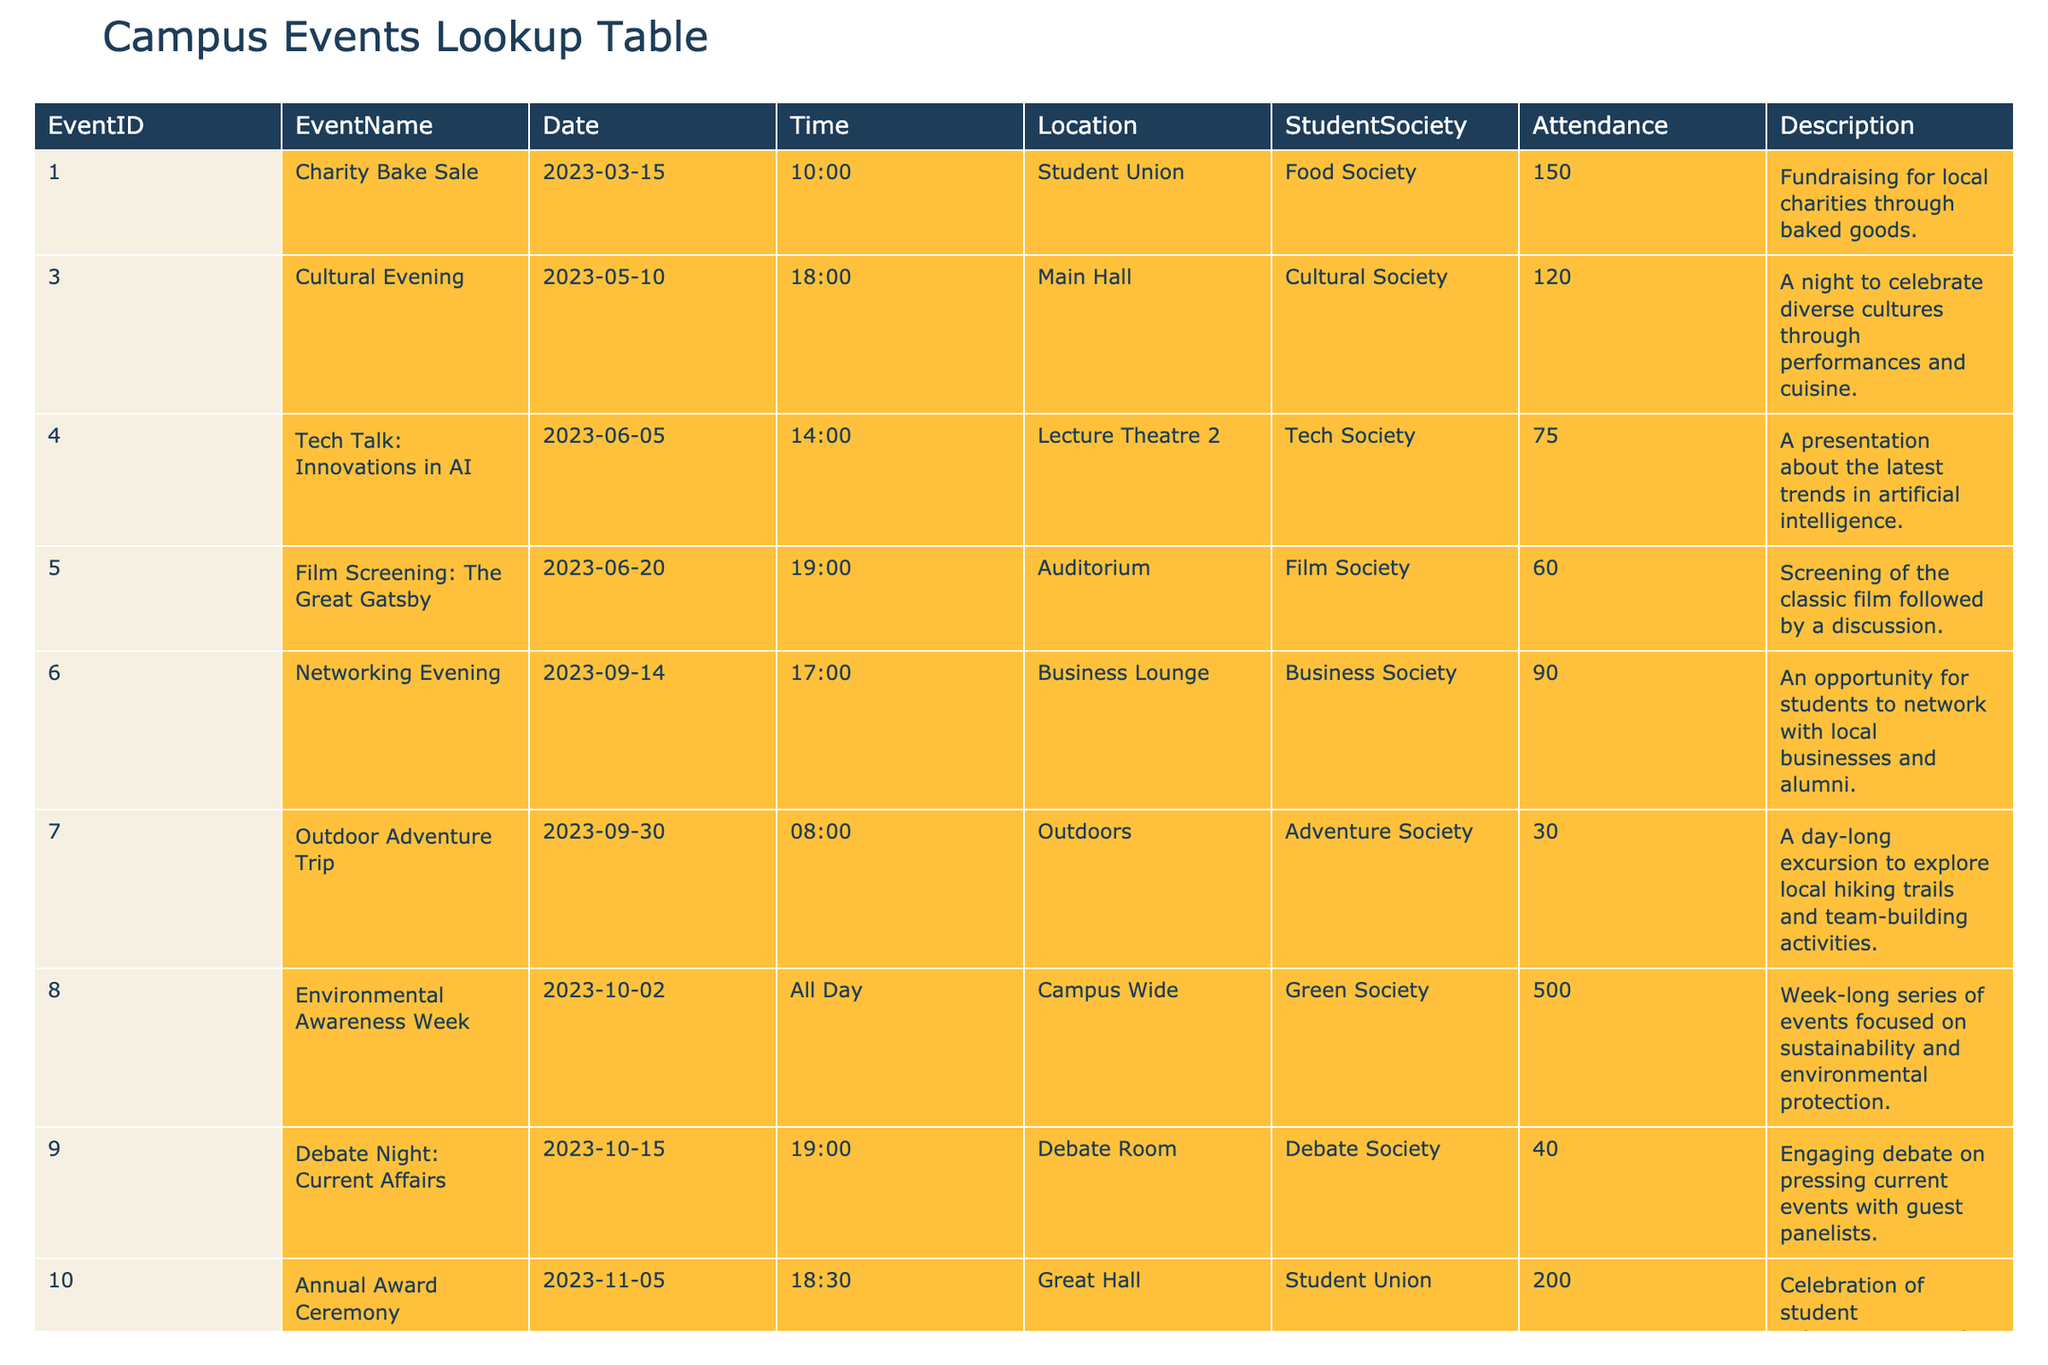what was the attendance for the Charity Bake Sale? The attendance for the Charity Bake Sale can be found in the table under the Attendance column for EventID 1. It states that the attendance was 150.
Answer: 150 what event had the highest attendance? To find the event with the highest attendance, I will compare the Attendance values for all events listed in the table. The Environmental Awareness Week has the highest attendance at 500.
Answer: Environmental Awareness Week how many events were held in September 2023? I will look at the Date column and identify the events that fall in September 2023. The Networking Evening and the Outdoor Adventure Trip are the two events in September. Therefore, there were 2 events held in that month.
Answer: 2 which society organized a Tech Talk? I can refer to the table and see that the event named "Tech Talk: Innovations in AI" was organized by the Tech Society, as indicated in the Student Society column for EventID 4.
Answer: Tech Society what was the total attendance for events organized by the Film Society and the Green Society? The Film Society had an attendance of 60 for the Film Screening event, and the Green Society had an attendance of 500 for the Environmental Awareness Week. I will add these two values: 60 + 500 = 560, giving a total attendance of 560.
Answer: 560 was the Outdoor Adventure Trip the only event with an attendance below 50? I will check the Attendance column for all events to see if any had attendance below 50. The Outdoor Adventure Trip had an attendance of 30, but there is also the Film Screening with 60, and others above 50. Therefore, the Outdoor Adventure Trip is not the only event below 50, as there are none lower.
Answer: False what is the average attendance across all events? To calculate the average attendance, I will first sum all the attendance values: 150 + 120 + 75 + 60 + 90 + 30 + 500 + 40 + 200 = 1265. Then, I will divide this by the total number of events, which is 10: 1265 / 10 = 126.5. Therefore, the average attendance across all events is 126.5.
Answer: 126.5 which event took place on October 15th, 2023? I can look for the Date column and find the entry for October 15th, 2023. The event listed for that date is the Debate Night: Current Affairs.
Answer: Debate Night: Current Affairs how many events were held in the Student Union location? I will check the Location column for the Student Union and identify the events that occurred there. The Charity Bake Sale and the Annual Award Ceremony were both held in the Student Union, giving a total of 2 events.
Answer: 2 is the Time for the Annual Award Ceremony later than 19:00? I will check the Time for the Annual Award Ceremony, which is 18:30. Since 18:30 is earlier than 19:00, therefore the answer is no.
Answer: No 